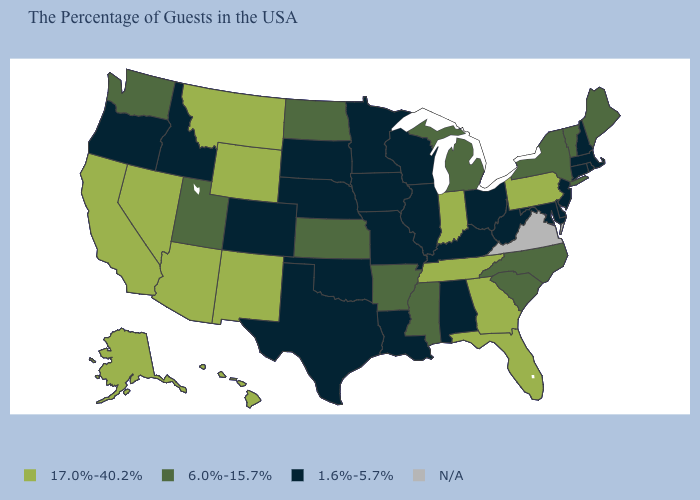Name the states that have a value in the range N/A?
Keep it brief. Virginia. Which states hav the highest value in the West?
Quick response, please. Wyoming, New Mexico, Montana, Arizona, Nevada, California, Alaska, Hawaii. What is the value of North Carolina?
Give a very brief answer. 6.0%-15.7%. Name the states that have a value in the range 6.0%-15.7%?
Quick response, please. Maine, Vermont, New York, North Carolina, South Carolina, Michigan, Mississippi, Arkansas, Kansas, North Dakota, Utah, Washington. Which states hav the highest value in the Northeast?
Keep it brief. Pennsylvania. Among the states that border Wisconsin , does Minnesota have the lowest value?
Write a very short answer. Yes. What is the value of Virginia?
Answer briefly. N/A. Does Arizona have the lowest value in the West?
Keep it brief. No. What is the value of South Carolina?
Write a very short answer. 6.0%-15.7%. Does New Hampshire have the lowest value in the USA?
Concise answer only. Yes. What is the value of New Jersey?
Answer briefly. 1.6%-5.7%. Which states have the highest value in the USA?
Quick response, please. Pennsylvania, Florida, Georgia, Indiana, Tennessee, Wyoming, New Mexico, Montana, Arizona, Nevada, California, Alaska, Hawaii. Name the states that have a value in the range 17.0%-40.2%?
Write a very short answer. Pennsylvania, Florida, Georgia, Indiana, Tennessee, Wyoming, New Mexico, Montana, Arizona, Nevada, California, Alaska, Hawaii. Is the legend a continuous bar?
Short answer required. No. What is the lowest value in states that border Iowa?
Be succinct. 1.6%-5.7%. 